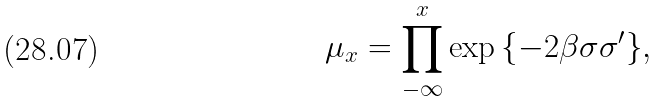Convert formula to latex. <formula><loc_0><loc_0><loc_500><loc_500>\mu _ { x } = \prod _ { - \infty } ^ { x } \exp { \{ - 2 \beta \sigma \sigma ^ { \prime } \} } ,</formula> 